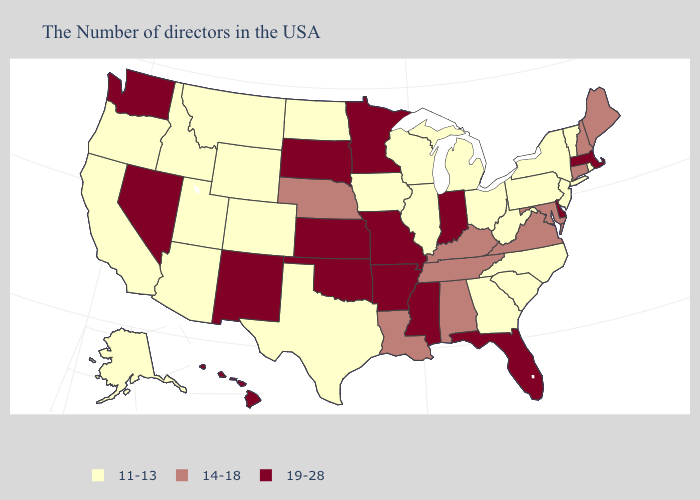Does Colorado have a higher value than Texas?
Answer briefly. No. Name the states that have a value in the range 11-13?
Be succinct. Rhode Island, Vermont, New York, New Jersey, Pennsylvania, North Carolina, South Carolina, West Virginia, Ohio, Georgia, Michigan, Wisconsin, Illinois, Iowa, Texas, North Dakota, Wyoming, Colorado, Utah, Montana, Arizona, Idaho, California, Oregon, Alaska. What is the lowest value in states that border Indiana?
Keep it brief. 11-13. What is the value of Hawaii?
Write a very short answer. 19-28. How many symbols are there in the legend?
Short answer required. 3. Name the states that have a value in the range 11-13?
Concise answer only. Rhode Island, Vermont, New York, New Jersey, Pennsylvania, North Carolina, South Carolina, West Virginia, Ohio, Georgia, Michigan, Wisconsin, Illinois, Iowa, Texas, North Dakota, Wyoming, Colorado, Utah, Montana, Arizona, Idaho, California, Oregon, Alaska. What is the highest value in states that border Nevada?
Concise answer only. 11-13. Name the states that have a value in the range 14-18?
Give a very brief answer. Maine, New Hampshire, Connecticut, Maryland, Virginia, Kentucky, Alabama, Tennessee, Louisiana, Nebraska. What is the highest value in states that border Arkansas?
Keep it brief. 19-28. Name the states that have a value in the range 14-18?
Give a very brief answer. Maine, New Hampshire, Connecticut, Maryland, Virginia, Kentucky, Alabama, Tennessee, Louisiana, Nebraska. What is the value of Vermont?
Short answer required. 11-13. Does Arizona have the same value as Oregon?
Quick response, please. Yes. What is the value of Nebraska?
Write a very short answer. 14-18. Which states have the highest value in the USA?
Keep it brief. Massachusetts, Delaware, Florida, Indiana, Mississippi, Missouri, Arkansas, Minnesota, Kansas, Oklahoma, South Dakota, New Mexico, Nevada, Washington, Hawaii. 